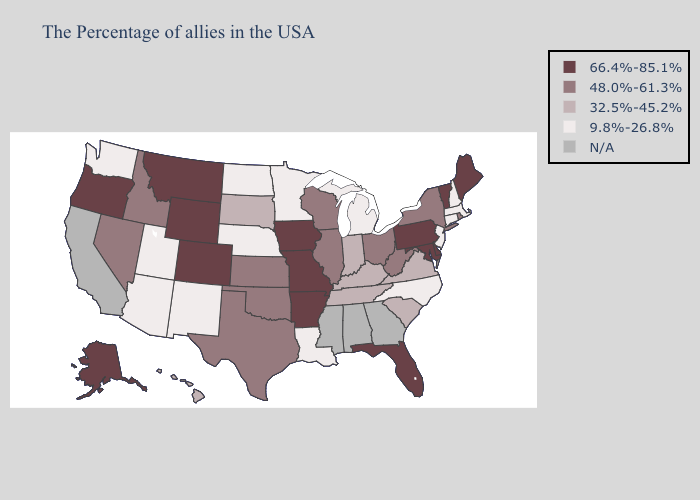Among the states that border Connecticut , does New York have the highest value?
Keep it brief. Yes. What is the value of Mississippi?
Concise answer only. N/A. What is the highest value in states that border Alabama?
Concise answer only. 66.4%-85.1%. Name the states that have a value in the range N/A?
Answer briefly. Georgia, Alabama, Mississippi, California. Name the states that have a value in the range N/A?
Keep it brief. Georgia, Alabama, Mississippi, California. Name the states that have a value in the range 66.4%-85.1%?
Answer briefly. Maine, Vermont, Delaware, Maryland, Pennsylvania, Florida, Missouri, Arkansas, Iowa, Wyoming, Colorado, Montana, Oregon, Alaska. Does Washington have the lowest value in the USA?
Give a very brief answer. Yes. Does Hawaii have the highest value in the USA?
Quick response, please. No. What is the value of Utah?
Write a very short answer. 9.8%-26.8%. What is the lowest value in the MidWest?
Concise answer only. 9.8%-26.8%. Name the states that have a value in the range N/A?
Write a very short answer. Georgia, Alabama, Mississippi, California. Does Louisiana have the lowest value in the USA?
Be succinct. Yes. What is the highest value in the Northeast ?
Give a very brief answer. 66.4%-85.1%. What is the highest value in the USA?
Concise answer only. 66.4%-85.1%. 